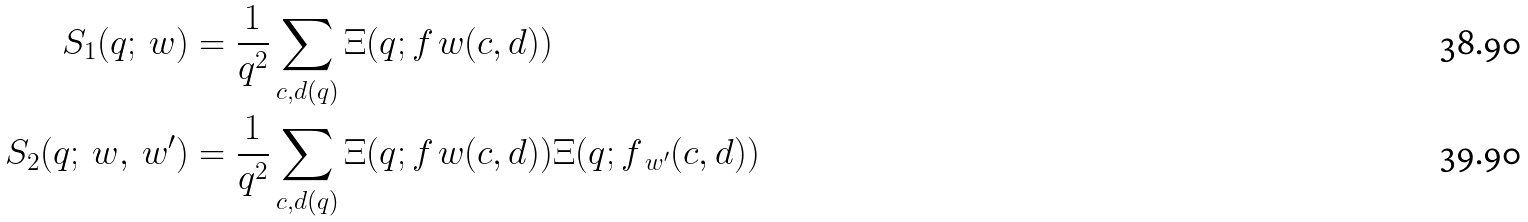<formula> <loc_0><loc_0><loc_500><loc_500>S _ { 1 } ( q ; \ w ) & = \frac { 1 } { q ^ { 2 } } \sum _ { c , d ( q ) } \Xi ( q ; f _ { \ } w ( c , d ) ) \\ S _ { 2 } ( q ; \ w , \ w ^ { \prime } ) & = \frac { 1 } { q ^ { 2 } } \sum _ { c , d ( q ) } \Xi ( q ; f _ { \ } w ( c , d ) ) \Xi ( q ; f _ { \ w ^ { \prime } } ( c , d ) )</formula> 